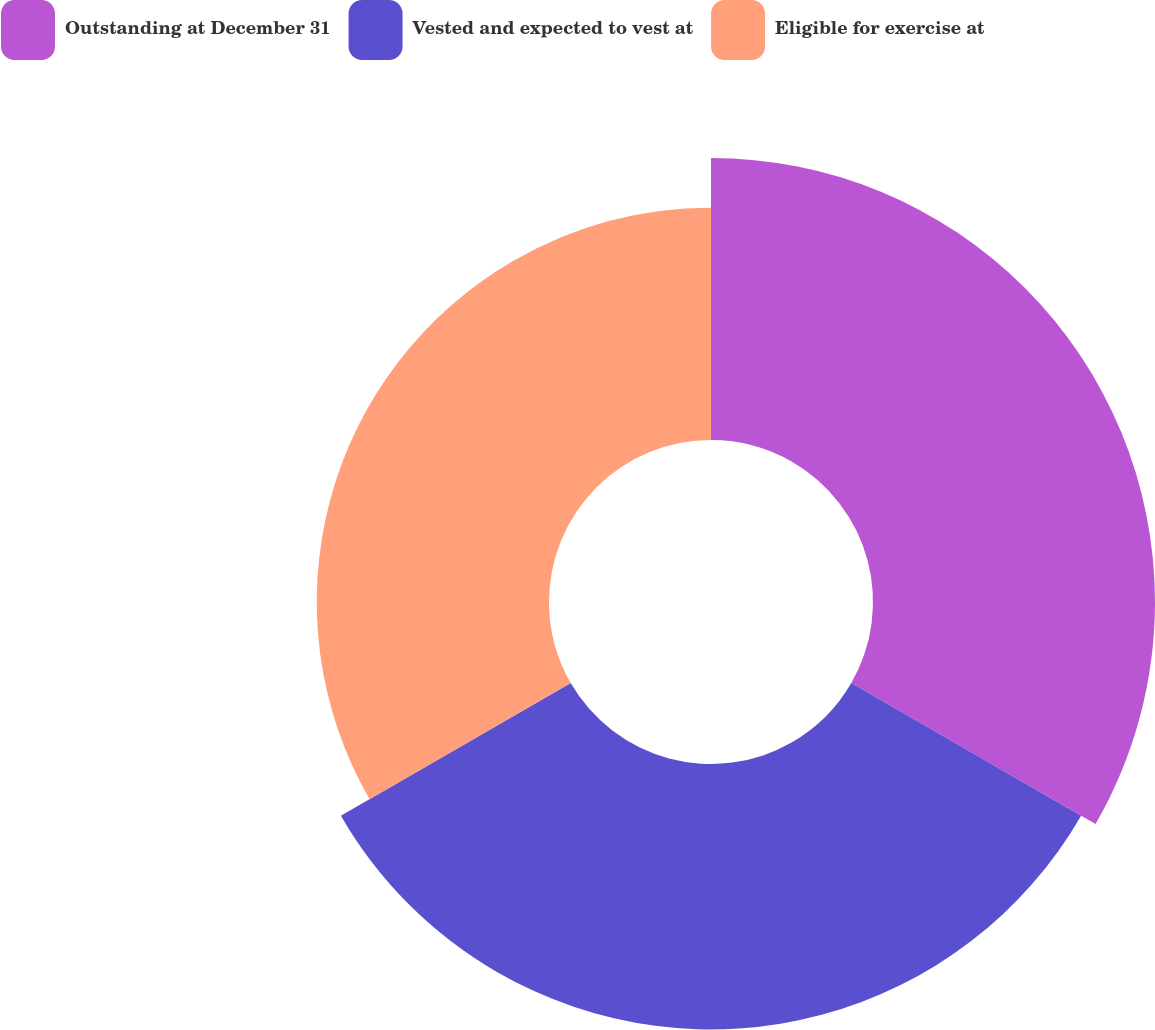Convert chart. <chart><loc_0><loc_0><loc_500><loc_500><pie_chart><fcel>Outstanding at December 31<fcel>Vested and expected to vest at<fcel>Eligible for exercise at<nl><fcel>36.17%<fcel>34.04%<fcel>29.79%<nl></chart> 